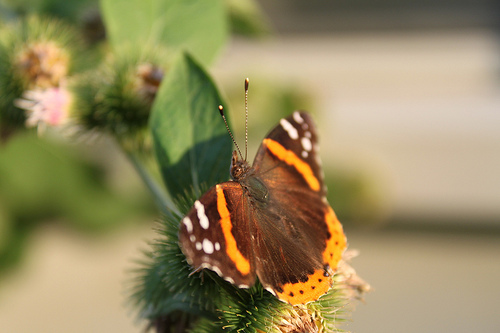<image>
Is the butterfly in the leaf? No. The butterfly is not contained within the leaf. These objects have a different spatial relationship. Where is the butterfly in relation to the plant? Is it on the plant? Yes. Looking at the image, I can see the butterfly is positioned on top of the plant, with the plant providing support. Is there a butterfly to the left of the leaf? No. The butterfly is not to the left of the leaf. From this viewpoint, they have a different horizontal relationship. 